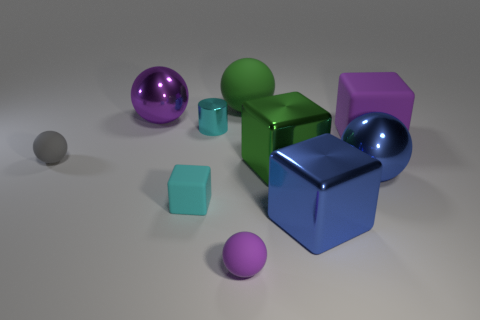Subtract all green spheres. How many spheres are left? 4 Subtract 2 spheres. How many spheres are left? 3 Subtract all purple cubes. How many cubes are left? 3 Subtract all blocks. How many objects are left? 6 Subtract all brown balls. How many purple cylinders are left? 0 Subtract 0 yellow cubes. How many objects are left? 10 Subtract all brown blocks. Subtract all cyan cylinders. How many blocks are left? 4 Subtract all shiny blocks. Subtract all cyan cylinders. How many objects are left? 7 Add 4 blue blocks. How many blue blocks are left? 5 Add 8 big green cylinders. How many big green cylinders exist? 8 